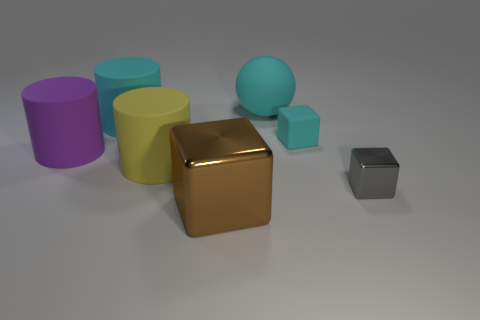How many big rubber objects are left of the cyan rubber cylinder and behind the cyan rubber cylinder? 0 